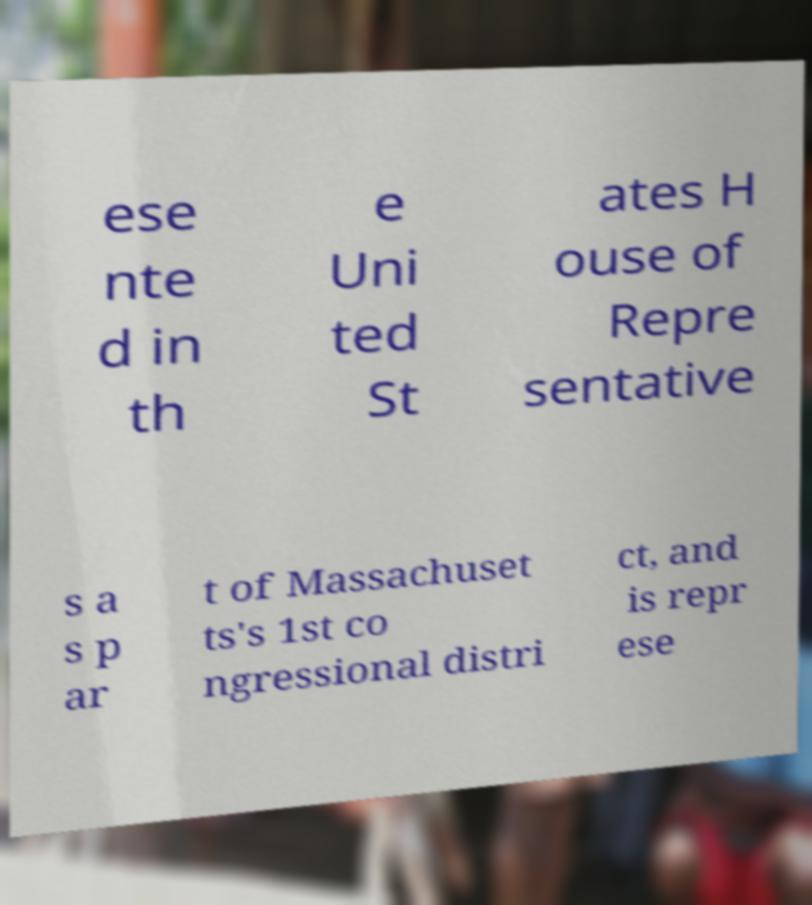Could you assist in decoding the text presented in this image and type it out clearly? ese nte d in th e Uni ted St ates H ouse of Repre sentative s a s p ar t of Massachuset ts's 1st co ngressional distri ct, and is repr ese 